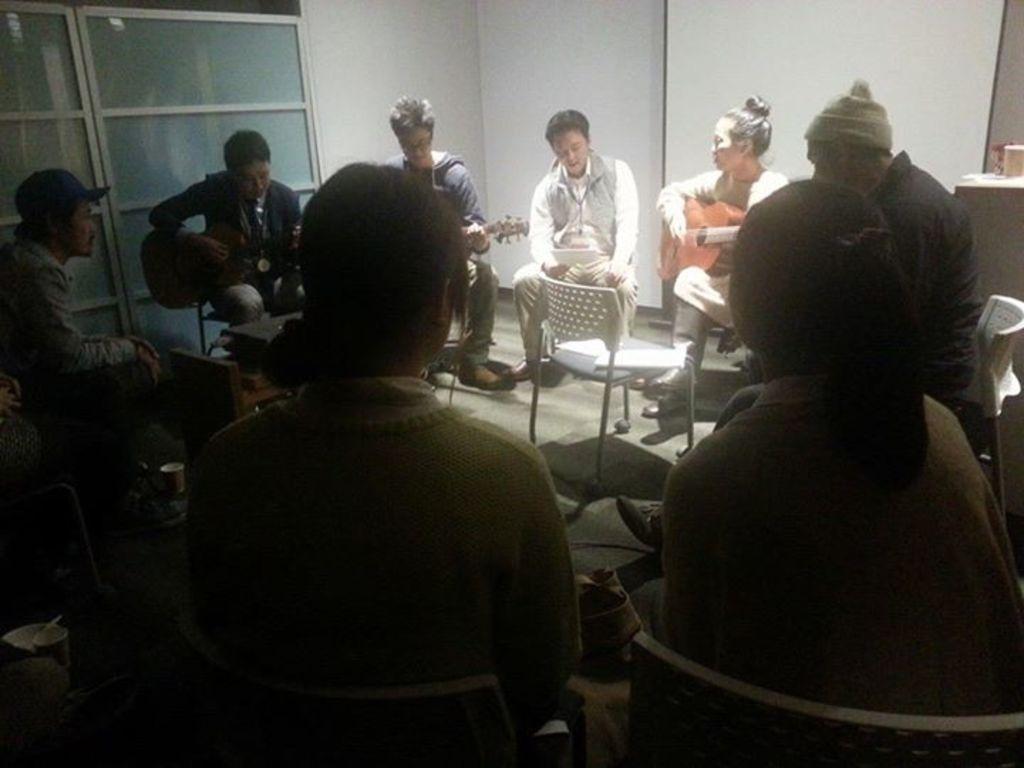In one or two sentences, can you explain what this image depicts? This picture describes about group of people, they are all seated on the chairs, and few people are playing guitars. 